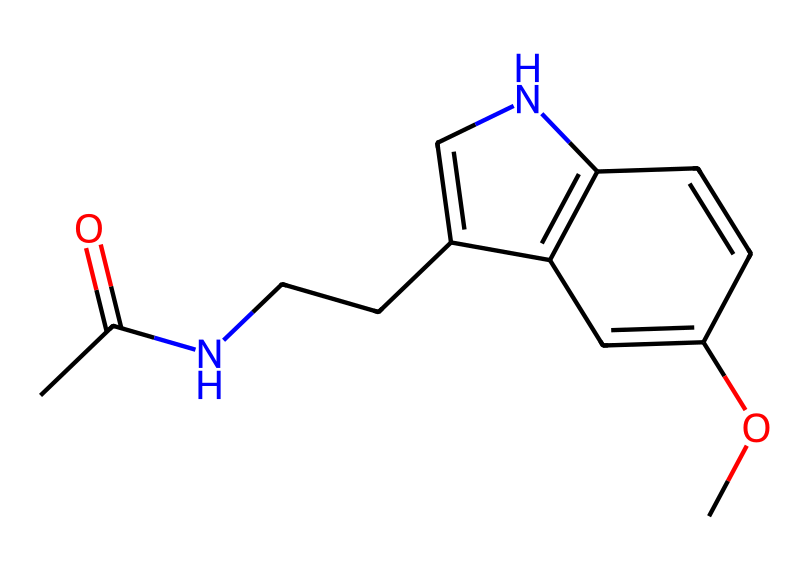What is the molecular weight of the compound? To determine the molecular weight, we need to sum the atomic weights of all the atoms in the molecule as represented in its SMILES notation. For this compound, it comprises elements including carbon, hydrogen, nitrogen, and oxygen. Calculating these: C (12.01), H (1.008), N (14.01), and O (16.00), we find a total molecular weight approximately of 232.25 g/mol.
Answer: 232.25 g/mol How many rings are present in the structure? In the given SMILES representation, by interpreting the structure, we observe the presence of one aromatic ring (as indicated by the "c" in the SMILES) that is part of two fused rings. Thus, we conclude there are two rings in total.
Answer: 2 Which element is centrally involved in the imide functional group? The imide functional group includes the nitrogen atom, which is bonded to the carbonyl carbon. This is a crucial aspect for determining the properties of imides.
Answer: nitrogen How many different elements are present in the structure? By identifying the distinct elements represented in the SMILES, we count the following: carbon (C), hydrogen (H), nitrogen (N), and oxygen (O). This totals to four different elements present in this chemical structure.
Answer: 4 What is the primary function of this molecule in the body? This molecule, which is melatonin, plays a crucial role in regulating sleep-wake cycles, which makes it a key hormone in the body's circadian rhythm.
Answer: sleep regulation What kind of interactions might this molecule have with biological receptors? Given its structure, melatonin can fit into specific receptors that recognize its shape, indicating it likely engages in hydrogen bonding and hydrophobic interactions, thus modulating physiological responses.
Answer: hydrogen bonding and hydrophobic interactions 